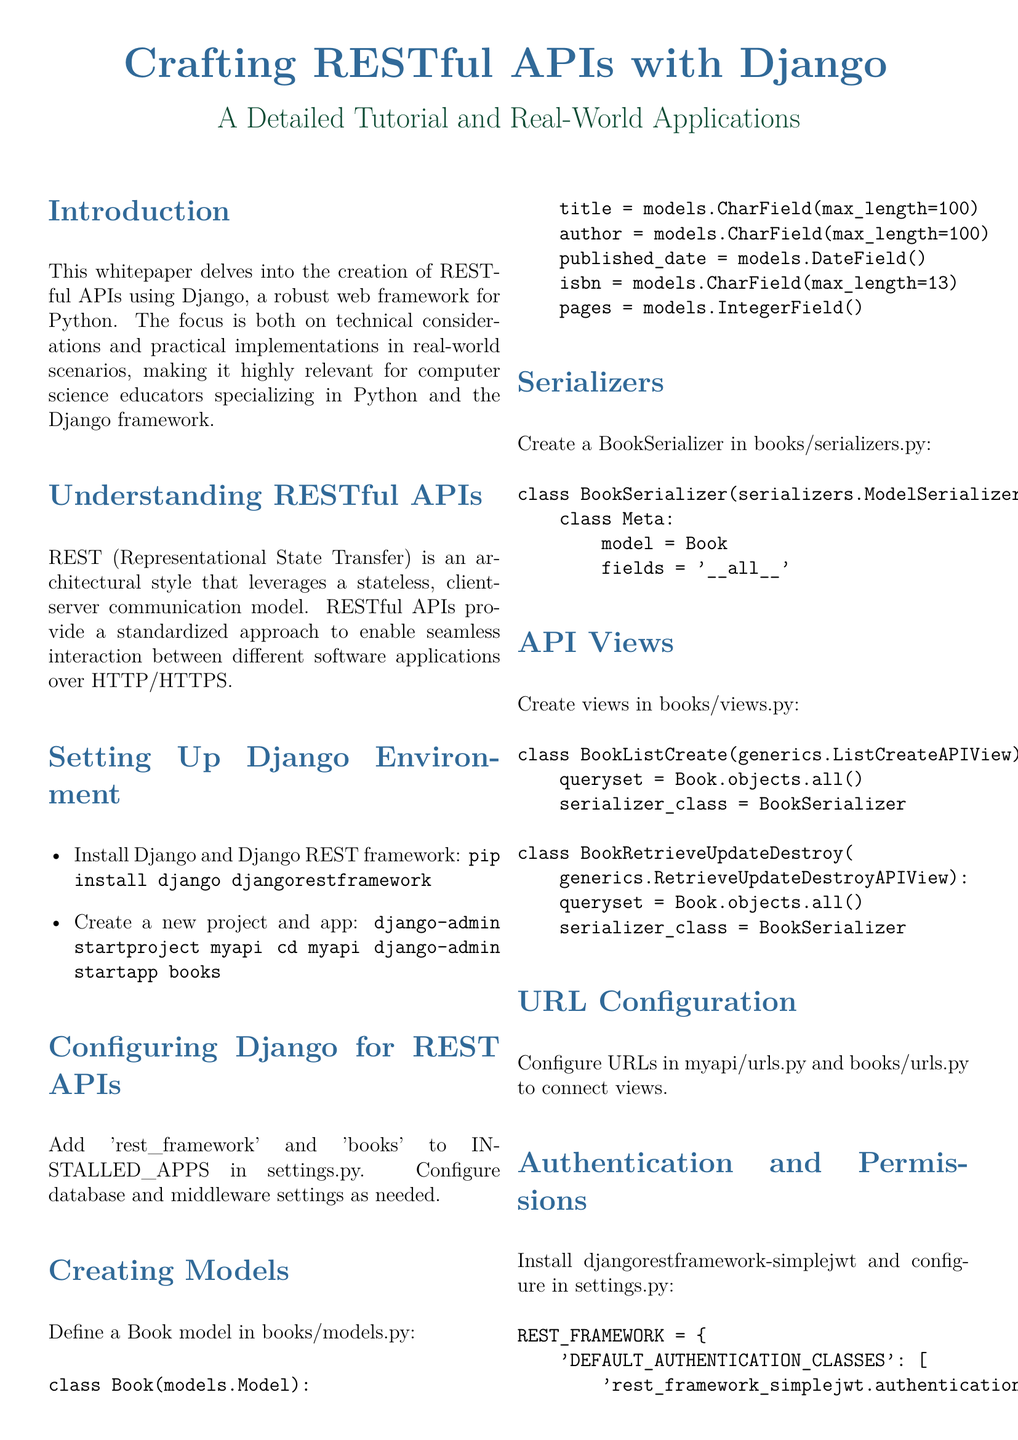What is the main focus of the whitepaper? The main focus of the whitepaper is the creation of RESTful APIs using Django, addressing both technical considerations and practical implementations.
Answer: RESTful APIs using Django What command is used to install Django? The command listed in the document for installing Django is part of the instructions for setting up the environment.
Answer: pip install django djangorestframework What does the Book model represent? The Book model is defined to hold data related to books, including attributes such as title, author, and published date.
Answer: Book What is the type of authentication configured in the document? The document specifies a particular class for handling authentication within the Django REST framework.
Answer: JWTAuthentication What is the purpose of the BookSerializer? The BookSerializer is used to convert Book model instances into JSON format and vice versa, allowing for API data handling.
Answer: Convert Book model instances What method is used to test the creation of a book? The method mentioned in the testing section of the document is designed to validate a specific functionality in the API.
Answer: test_create_book How many attributes does the Book model have? The Book model contains several attributes, representing various characteristics associated with a book.
Answer: Five Which Django command is used to start a new project? The command referred to in the setting up section is used to initialize a new Django project from the command line.
Answer: django-admin startproject myapi What is a practical application mentioned for the API? The document outlines specific areas where the RESTful API can be integrated into real-world scenarios.
Answer: Library management systems 